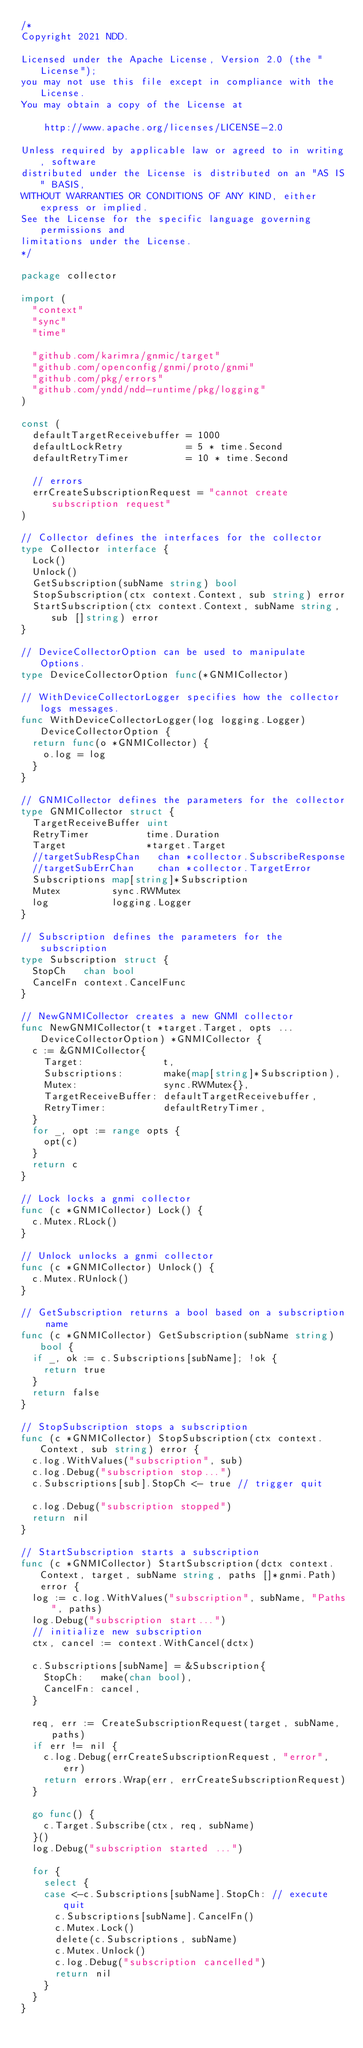Convert code to text. <code><loc_0><loc_0><loc_500><loc_500><_Go_>/*
Copyright 2021 NDD.

Licensed under the Apache License, Version 2.0 (the "License");
you may not use this file except in compliance with the License.
You may obtain a copy of the License at

    http://www.apache.org/licenses/LICENSE-2.0

Unless required by applicable law or agreed to in writing, software
distributed under the License is distributed on an "AS IS" BASIS,
WITHOUT WARRANTIES OR CONDITIONS OF ANY KIND, either express or implied.
See the License for the specific language governing permissions and
limitations under the License.
*/

package collector

import (
	"context"
	"sync"
	"time"

	"github.com/karimra/gnmic/target"
	"github.com/openconfig/gnmi/proto/gnmi"
	"github.com/pkg/errors"
	"github.com/yndd/ndd-runtime/pkg/logging"
)

const (
	defaultTargetReceivebuffer = 1000
	defaultLockRetry           = 5 * time.Second
	defaultRetryTimer          = 10 * time.Second

	// errors
	errCreateSubscriptionRequest = "cannot create subscription request"
)

// Collector defines the interfaces for the collector
type Collector interface {
	Lock()
	Unlock()
	GetSubscription(subName string) bool
	StopSubscription(ctx context.Context, sub string) error
	StartSubscription(ctx context.Context, subName string, sub []string) error
}

// DeviceCollectorOption can be used to manipulate Options.
type DeviceCollectorOption func(*GNMICollector)

// WithDeviceCollectorLogger specifies how the collector logs messages.
func WithDeviceCollectorLogger(log logging.Logger) DeviceCollectorOption {
	return func(o *GNMICollector) {
		o.log = log
	}
}

// GNMICollector defines the parameters for the collector
type GNMICollector struct {
	TargetReceiveBuffer uint
	RetryTimer          time.Duration
	Target              *target.Target
	//targetSubRespChan   chan *collector.SubscribeResponse
	//targetSubErrChan    chan *collector.TargetError
	Subscriptions map[string]*Subscription
	Mutex         sync.RWMutex
	log           logging.Logger
}

// Subscription defines the parameters for the subscription
type Subscription struct {
	StopCh   chan bool
	CancelFn context.CancelFunc
}

// NewGNMICollector creates a new GNMI collector
func NewGNMICollector(t *target.Target, opts ...DeviceCollectorOption) *GNMICollector {
	c := &GNMICollector{
		Target:              t,
		Subscriptions:       make(map[string]*Subscription),
		Mutex:               sync.RWMutex{},
		TargetReceiveBuffer: defaultTargetReceivebuffer,
		RetryTimer:          defaultRetryTimer,
	}
	for _, opt := range opts {
		opt(c)
	}
	return c
}

// Lock locks a gnmi collector
func (c *GNMICollector) Lock() {
	c.Mutex.RLock()
}

// Unlock unlocks a gnmi collector
func (c *GNMICollector) Unlock() {
	c.Mutex.RUnlock()
}

// GetSubscription returns a bool based on a subscription name
func (c *GNMICollector) GetSubscription(subName string) bool {
	if _, ok := c.Subscriptions[subName]; !ok {
		return true
	}
	return false
}

// StopSubscription stops a subscription
func (c *GNMICollector) StopSubscription(ctx context.Context, sub string) error {
	c.log.WithValues("subscription", sub)
	c.log.Debug("subscription stop...")
	c.Subscriptions[sub].StopCh <- true // trigger quit

	c.log.Debug("subscription stopped")
	return nil
}

// StartSubscription starts a subscription
func (c *GNMICollector) StartSubscription(dctx context.Context, target, subName string, paths []*gnmi.Path) error {
	log := c.log.WithValues("subscription", subName, "Paths", paths)
	log.Debug("subscription start...")
	// initialize new subscription
	ctx, cancel := context.WithCancel(dctx)

	c.Subscriptions[subName] = &Subscription{
		StopCh:   make(chan bool),
		CancelFn: cancel,
	}

	req, err := CreateSubscriptionRequest(target, subName, paths)
	if err != nil {
		c.log.Debug(errCreateSubscriptionRequest, "error", err)
		return errors.Wrap(err, errCreateSubscriptionRequest)
	}

	go func() {
		c.Target.Subscribe(ctx, req, subName)
	}()
	log.Debug("subscription started ...")

	for {
		select {
		case <-c.Subscriptions[subName].StopCh: // execute quit
			c.Subscriptions[subName].CancelFn()
			c.Mutex.Lock()
			delete(c.Subscriptions, subName)
			c.Mutex.Unlock()
			c.log.Debug("subscription cancelled")
			return nil
		}
	}
}
</code> 